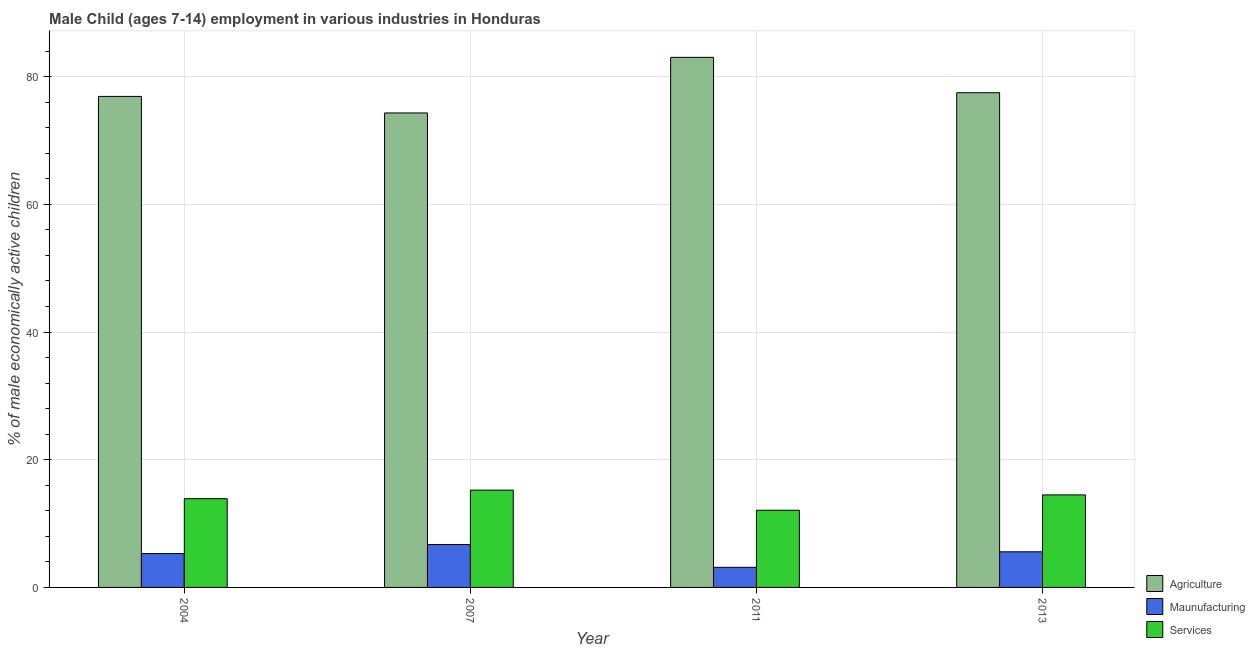How many different coloured bars are there?
Ensure brevity in your answer.  3. How many groups of bars are there?
Provide a succinct answer. 4. Are the number of bars on each tick of the X-axis equal?
Offer a very short reply. Yes. In how many cases, is the number of bars for a given year not equal to the number of legend labels?
Your response must be concise. 0. What is the percentage of economically active children in agriculture in 2011?
Ensure brevity in your answer.  83.02. Across all years, what is the maximum percentage of economically active children in manufacturing?
Provide a succinct answer. 6.72. Across all years, what is the minimum percentage of economically active children in services?
Give a very brief answer. 12.09. What is the total percentage of economically active children in services in the graph?
Give a very brief answer. 55.72. What is the difference between the percentage of economically active children in services in 2004 and that in 2011?
Provide a short and direct response. 1.81. What is the difference between the percentage of economically active children in services in 2011 and the percentage of economically active children in agriculture in 2013?
Ensure brevity in your answer.  -2.4. What is the average percentage of economically active children in services per year?
Your answer should be compact. 13.93. What is the ratio of the percentage of economically active children in agriculture in 2004 to that in 2013?
Your answer should be compact. 0.99. Is the percentage of economically active children in agriculture in 2004 less than that in 2013?
Provide a short and direct response. Yes. Is the difference between the percentage of economically active children in agriculture in 2007 and 2013 greater than the difference between the percentage of economically active children in manufacturing in 2007 and 2013?
Offer a very short reply. No. What is the difference between the highest and the lowest percentage of economically active children in manufacturing?
Provide a short and direct response. 3.57. What does the 2nd bar from the left in 2011 represents?
Your response must be concise. Maunufacturing. What does the 1st bar from the right in 2011 represents?
Give a very brief answer. Services. Is it the case that in every year, the sum of the percentage of economically active children in agriculture and percentage of economically active children in manufacturing is greater than the percentage of economically active children in services?
Make the answer very short. Yes. How many bars are there?
Your response must be concise. 12. What is the difference between two consecutive major ticks on the Y-axis?
Offer a very short reply. 20. How many legend labels are there?
Provide a short and direct response. 3. How are the legend labels stacked?
Give a very brief answer. Vertical. What is the title of the graph?
Give a very brief answer. Male Child (ages 7-14) employment in various industries in Honduras. What is the label or title of the X-axis?
Your answer should be very brief. Year. What is the label or title of the Y-axis?
Provide a succinct answer. % of male economically active children. What is the % of male economically active children of Agriculture in 2004?
Your response must be concise. 76.9. What is the % of male economically active children in Agriculture in 2007?
Make the answer very short. 74.31. What is the % of male economically active children of Maunufacturing in 2007?
Provide a short and direct response. 6.72. What is the % of male economically active children in Services in 2007?
Offer a terse response. 15.24. What is the % of male economically active children in Agriculture in 2011?
Keep it short and to the point. 83.02. What is the % of male economically active children of Maunufacturing in 2011?
Offer a terse response. 3.15. What is the % of male economically active children of Services in 2011?
Keep it short and to the point. 12.09. What is the % of male economically active children in Agriculture in 2013?
Provide a short and direct response. 77.48. What is the % of male economically active children in Maunufacturing in 2013?
Make the answer very short. 5.58. What is the % of male economically active children in Services in 2013?
Make the answer very short. 14.49. Across all years, what is the maximum % of male economically active children of Agriculture?
Make the answer very short. 83.02. Across all years, what is the maximum % of male economically active children of Maunufacturing?
Provide a short and direct response. 6.72. Across all years, what is the maximum % of male economically active children in Services?
Your response must be concise. 15.24. Across all years, what is the minimum % of male economically active children in Agriculture?
Your answer should be very brief. 74.31. Across all years, what is the minimum % of male economically active children of Maunufacturing?
Provide a succinct answer. 3.15. Across all years, what is the minimum % of male economically active children in Services?
Your answer should be very brief. 12.09. What is the total % of male economically active children in Agriculture in the graph?
Your answer should be compact. 311.71. What is the total % of male economically active children in Maunufacturing in the graph?
Give a very brief answer. 20.75. What is the total % of male economically active children of Services in the graph?
Provide a succinct answer. 55.72. What is the difference between the % of male economically active children in Agriculture in 2004 and that in 2007?
Ensure brevity in your answer.  2.59. What is the difference between the % of male economically active children of Maunufacturing in 2004 and that in 2007?
Your answer should be very brief. -1.42. What is the difference between the % of male economically active children of Services in 2004 and that in 2007?
Make the answer very short. -1.34. What is the difference between the % of male economically active children in Agriculture in 2004 and that in 2011?
Your response must be concise. -6.12. What is the difference between the % of male economically active children in Maunufacturing in 2004 and that in 2011?
Your response must be concise. 2.15. What is the difference between the % of male economically active children in Services in 2004 and that in 2011?
Make the answer very short. 1.81. What is the difference between the % of male economically active children in Agriculture in 2004 and that in 2013?
Ensure brevity in your answer.  -0.58. What is the difference between the % of male economically active children in Maunufacturing in 2004 and that in 2013?
Make the answer very short. -0.28. What is the difference between the % of male economically active children in Services in 2004 and that in 2013?
Give a very brief answer. -0.59. What is the difference between the % of male economically active children of Agriculture in 2007 and that in 2011?
Offer a very short reply. -8.71. What is the difference between the % of male economically active children in Maunufacturing in 2007 and that in 2011?
Make the answer very short. 3.57. What is the difference between the % of male economically active children in Services in 2007 and that in 2011?
Provide a succinct answer. 3.15. What is the difference between the % of male economically active children in Agriculture in 2007 and that in 2013?
Offer a terse response. -3.17. What is the difference between the % of male economically active children in Maunufacturing in 2007 and that in 2013?
Your answer should be very brief. 1.14. What is the difference between the % of male economically active children in Services in 2007 and that in 2013?
Offer a very short reply. 0.75. What is the difference between the % of male economically active children in Agriculture in 2011 and that in 2013?
Provide a succinct answer. 5.54. What is the difference between the % of male economically active children of Maunufacturing in 2011 and that in 2013?
Provide a short and direct response. -2.43. What is the difference between the % of male economically active children of Agriculture in 2004 and the % of male economically active children of Maunufacturing in 2007?
Provide a succinct answer. 70.18. What is the difference between the % of male economically active children in Agriculture in 2004 and the % of male economically active children in Services in 2007?
Your response must be concise. 61.66. What is the difference between the % of male economically active children of Maunufacturing in 2004 and the % of male economically active children of Services in 2007?
Provide a succinct answer. -9.94. What is the difference between the % of male economically active children in Agriculture in 2004 and the % of male economically active children in Maunufacturing in 2011?
Your response must be concise. 73.75. What is the difference between the % of male economically active children of Agriculture in 2004 and the % of male economically active children of Services in 2011?
Provide a succinct answer. 64.81. What is the difference between the % of male economically active children in Maunufacturing in 2004 and the % of male economically active children in Services in 2011?
Your response must be concise. -6.79. What is the difference between the % of male economically active children in Agriculture in 2004 and the % of male economically active children in Maunufacturing in 2013?
Offer a very short reply. 71.32. What is the difference between the % of male economically active children in Agriculture in 2004 and the % of male economically active children in Services in 2013?
Provide a succinct answer. 62.41. What is the difference between the % of male economically active children in Maunufacturing in 2004 and the % of male economically active children in Services in 2013?
Make the answer very short. -9.19. What is the difference between the % of male economically active children of Agriculture in 2007 and the % of male economically active children of Maunufacturing in 2011?
Your response must be concise. 71.16. What is the difference between the % of male economically active children in Agriculture in 2007 and the % of male economically active children in Services in 2011?
Make the answer very short. 62.22. What is the difference between the % of male economically active children in Maunufacturing in 2007 and the % of male economically active children in Services in 2011?
Ensure brevity in your answer.  -5.37. What is the difference between the % of male economically active children of Agriculture in 2007 and the % of male economically active children of Maunufacturing in 2013?
Keep it short and to the point. 68.73. What is the difference between the % of male economically active children of Agriculture in 2007 and the % of male economically active children of Services in 2013?
Give a very brief answer. 59.82. What is the difference between the % of male economically active children of Maunufacturing in 2007 and the % of male economically active children of Services in 2013?
Your response must be concise. -7.77. What is the difference between the % of male economically active children of Agriculture in 2011 and the % of male economically active children of Maunufacturing in 2013?
Ensure brevity in your answer.  77.44. What is the difference between the % of male economically active children in Agriculture in 2011 and the % of male economically active children in Services in 2013?
Make the answer very short. 68.53. What is the difference between the % of male economically active children in Maunufacturing in 2011 and the % of male economically active children in Services in 2013?
Make the answer very short. -11.34. What is the average % of male economically active children of Agriculture per year?
Ensure brevity in your answer.  77.93. What is the average % of male economically active children in Maunufacturing per year?
Your response must be concise. 5.19. What is the average % of male economically active children of Services per year?
Your answer should be very brief. 13.93. In the year 2004, what is the difference between the % of male economically active children in Agriculture and % of male economically active children in Maunufacturing?
Your answer should be compact. 71.6. In the year 2004, what is the difference between the % of male economically active children of Agriculture and % of male economically active children of Services?
Your response must be concise. 63. In the year 2004, what is the difference between the % of male economically active children in Maunufacturing and % of male economically active children in Services?
Your response must be concise. -8.6. In the year 2007, what is the difference between the % of male economically active children in Agriculture and % of male economically active children in Maunufacturing?
Ensure brevity in your answer.  67.59. In the year 2007, what is the difference between the % of male economically active children of Agriculture and % of male economically active children of Services?
Your response must be concise. 59.07. In the year 2007, what is the difference between the % of male economically active children in Maunufacturing and % of male economically active children in Services?
Give a very brief answer. -8.52. In the year 2011, what is the difference between the % of male economically active children of Agriculture and % of male economically active children of Maunufacturing?
Offer a very short reply. 79.87. In the year 2011, what is the difference between the % of male economically active children in Agriculture and % of male economically active children in Services?
Make the answer very short. 70.93. In the year 2011, what is the difference between the % of male economically active children in Maunufacturing and % of male economically active children in Services?
Make the answer very short. -8.94. In the year 2013, what is the difference between the % of male economically active children of Agriculture and % of male economically active children of Maunufacturing?
Your answer should be compact. 71.9. In the year 2013, what is the difference between the % of male economically active children in Agriculture and % of male economically active children in Services?
Make the answer very short. 62.99. In the year 2013, what is the difference between the % of male economically active children of Maunufacturing and % of male economically active children of Services?
Your answer should be very brief. -8.91. What is the ratio of the % of male economically active children of Agriculture in 2004 to that in 2007?
Keep it short and to the point. 1.03. What is the ratio of the % of male economically active children in Maunufacturing in 2004 to that in 2007?
Ensure brevity in your answer.  0.79. What is the ratio of the % of male economically active children in Services in 2004 to that in 2007?
Offer a terse response. 0.91. What is the ratio of the % of male economically active children of Agriculture in 2004 to that in 2011?
Your answer should be compact. 0.93. What is the ratio of the % of male economically active children in Maunufacturing in 2004 to that in 2011?
Your response must be concise. 1.68. What is the ratio of the % of male economically active children in Services in 2004 to that in 2011?
Offer a very short reply. 1.15. What is the ratio of the % of male economically active children in Agriculture in 2004 to that in 2013?
Offer a terse response. 0.99. What is the ratio of the % of male economically active children in Maunufacturing in 2004 to that in 2013?
Make the answer very short. 0.95. What is the ratio of the % of male economically active children of Services in 2004 to that in 2013?
Offer a very short reply. 0.96. What is the ratio of the % of male economically active children in Agriculture in 2007 to that in 2011?
Keep it short and to the point. 0.9. What is the ratio of the % of male economically active children in Maunufacturing in 2007 to that in 2011?
Your answer should be very brief. 2.13. What is the ratio of the % of male economically active children of Services in 2007 to that in 2011?
Your response must be concise. 1.26. What is the ratio of the % of male economically active children of Agriculture in 2007 to that in 2013?
Make the answer very short. 0.96. What is the ratio of the % of male economically active children in Maunufacturing in 2007 to that in 2013?
Your response must be concise. 1.2. What is the ratio of the % of male economically active children in Services in 2007 to that in 2013?
Give a very brief answer. 1.05. What is the ratio of the % of male economically active children of Agriculture in 2011 to that in 2013?
Provide a short and direct response. 1.07. What is the ratio of the % of male economically active children of Maunufacturing in 2011 to that in 2013?
Make the answer very short. 0.56. What is the ratio of the % of male economically active children in Services in 2011 to that in 2013?
Your response must be concise. 0.83. What is the difference between the highest and the second highest % of male economically active children in Agriculture?
Your response must be concise. 5.54. What is the difference between the highest and the second highest % of male economically active children in Maunufacturing?
Your answer should be very brief. 1.14. What is the difference between the highest and the lowest % of male economically active children of Agriculture?
Offer a very short reply. 8.71. What is the difference between the highest and the lowest % of male economically active children in Maunufacturing?
Your answer should be compact. 3.57. What is the difference between the highest and the lowest % of male economically active children of Services?
Offer a terse response. 3.15. 